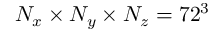<formula> <loc_0><loc_0><loc_500><loc_500>N _ { x } \times N _ { y } \times N _ { z } = 7 2 ^ { 3 }</formula> 